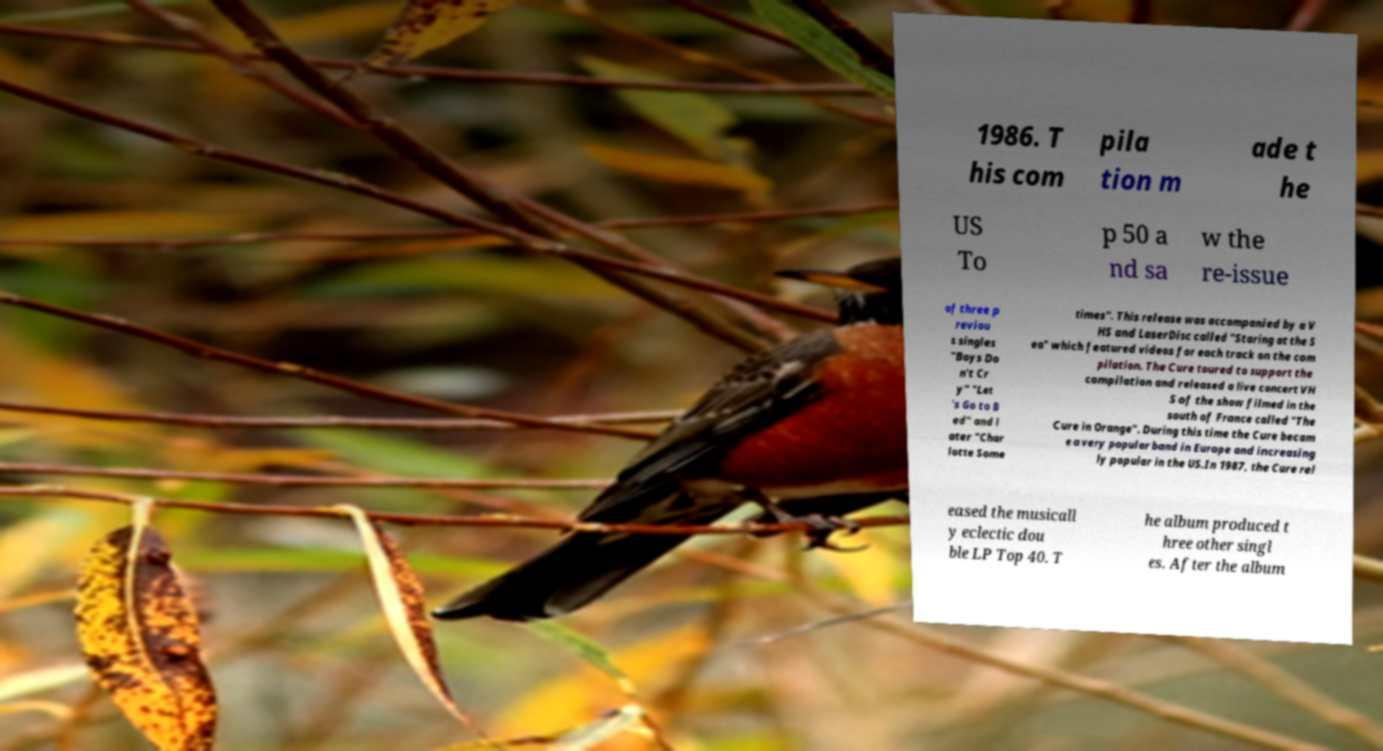Could you assist in decoding the text presented in this image and type it out clearly? 1986. T his com pila tion m ade t he US To p 50 a nd sa w the re-issue of three p reviou s singles "Boys Do n't Cr y" "Let 's Go to B ed" and l ater "Char lotte Some times". This release was accompanied by a V HS and LaserDisc called "Staring at the S ea" which featured videos for each track on the com pilation. The Cure toured to support the compilation and released a live concert VH S of the show filmed in the south of France called "The Cure in Orange". During this time the Cure becam e a very popular band in Europe and increasing ly popular in the US.In 1987, the Cure rel eased the musicall y eclectic dou ble LP Top 40. T he album produced t hree other singl es. After the album 